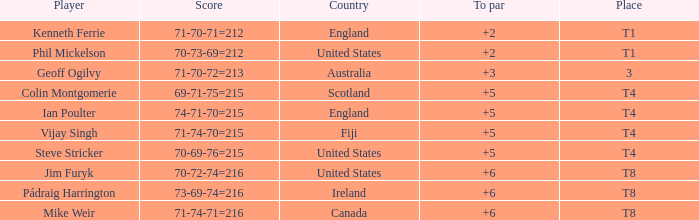What was mike weir's best score in comparison to par? 6.0. 